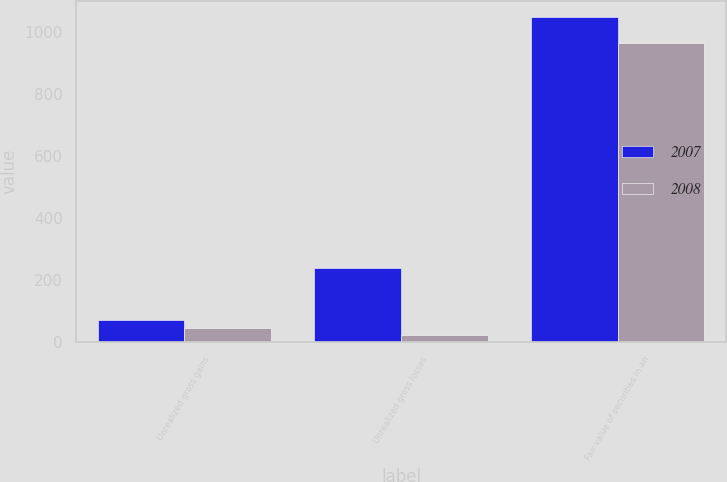Convert chart to OTSL. <chart><loc_0><loc_0><loc_500><loc_500><stacked_bar_chart><ecel><fcel>Unrealized gross gains<fcel>Unrealized gross losses<fcel>Fair value of securities in an<nl><fcel>2007<fcel>69.9<fcel>239<fcel>1046.1<nl><fcel>2008<fcel>43.5<fcel>22<fcel>964.6<nl></chart> 